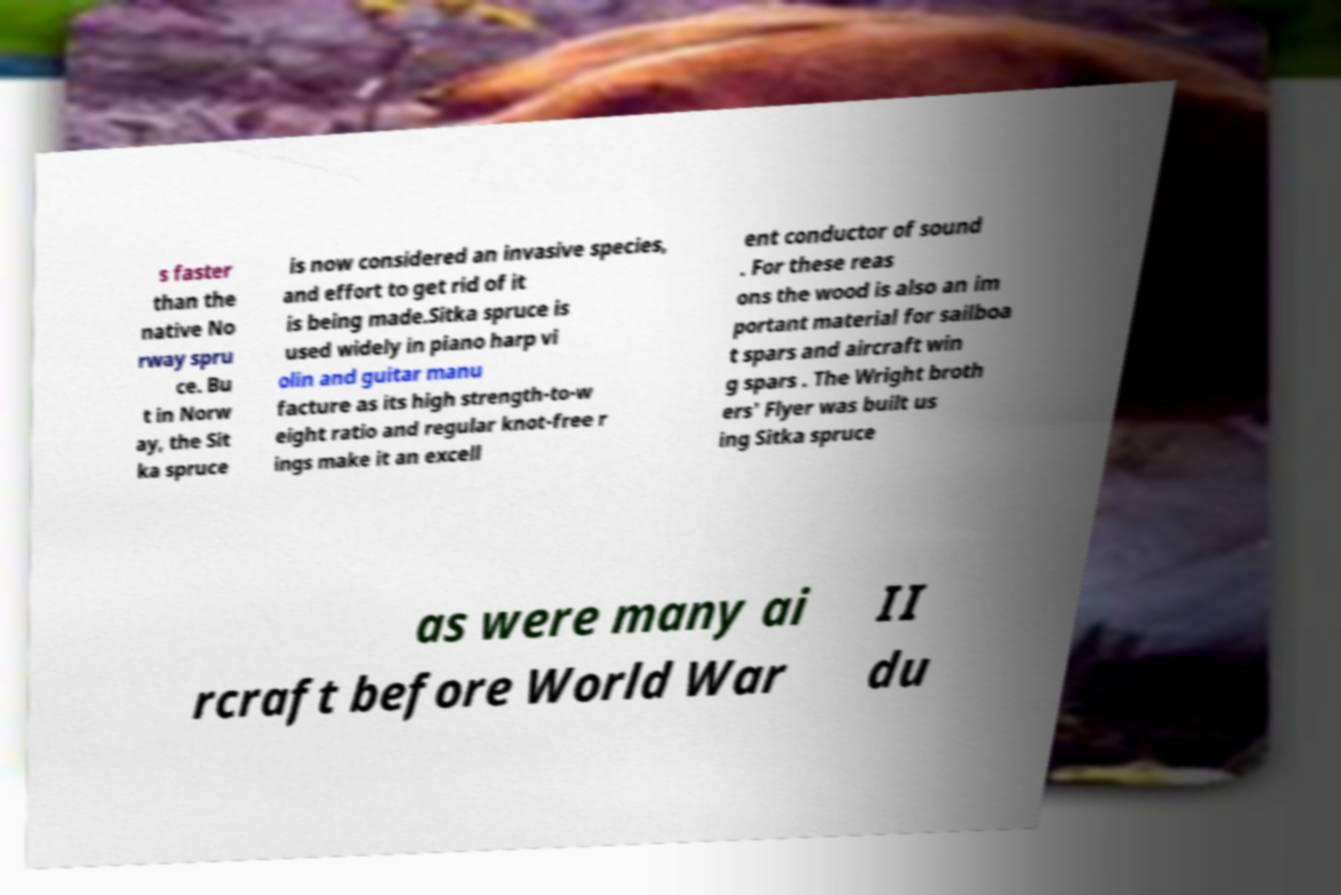What messages or text are displayed in this image? I need them in a readable, typed format. s faster than the native No rway spru ce. Bu t in Norw ay, the Sit ka spruce is now considered an invasive species, and effort to get rid of it is being made.Sitka spruce is used widely in piano harp vi olin and guitar manu facture as its high strength-to-w eight ratio and regular knot-free r ings make it an excell ent conductor of sound . For these reas ons the wood is also an im portant material for sailboa t spars and aircraft win g spars . The Wright broth ers' Flyer was built us ing Sitka spruce as were many ai rcraft before World War II du 